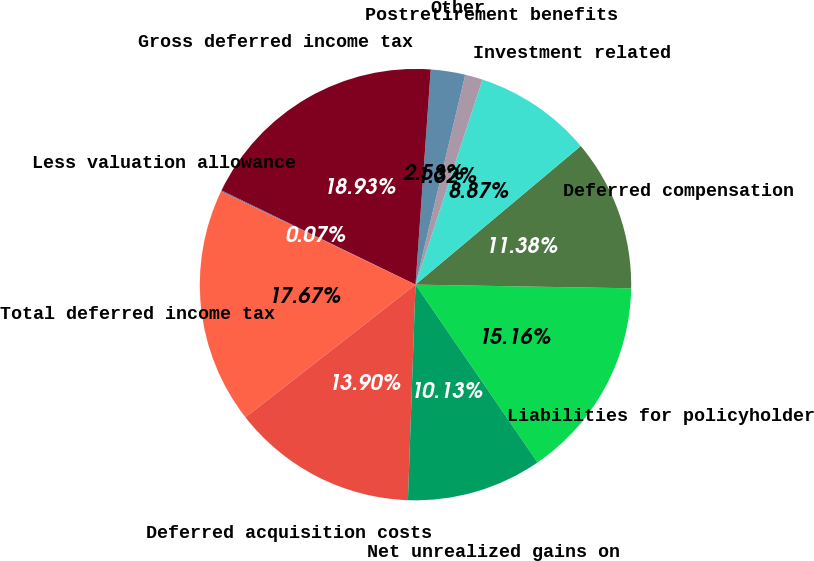Convert chart. <chart><loc_0><loc_0><loc_500><loc_500><pie_chart><fcel>Liabilities for policyholder<fcel>Deferred compensation<fcel>Investment related<fcel>Postretirement benefits<fcel>Other<fcel>Gross deferred income tax<fcel>Less valuation allowance<fcel>Total deferred income tax<fcel>Deferred acquisition costs<fcel>Net unrealized gains on<nl><fcel>15.16%<fcel>11.38%<fcel>8.87%<fcel>1.32%<fcel>2.58%<fcel>18.93%<fcel>0.07%<fcel>17.67%<fcel>13.9%<fcel>10.13%<nl></chart> 